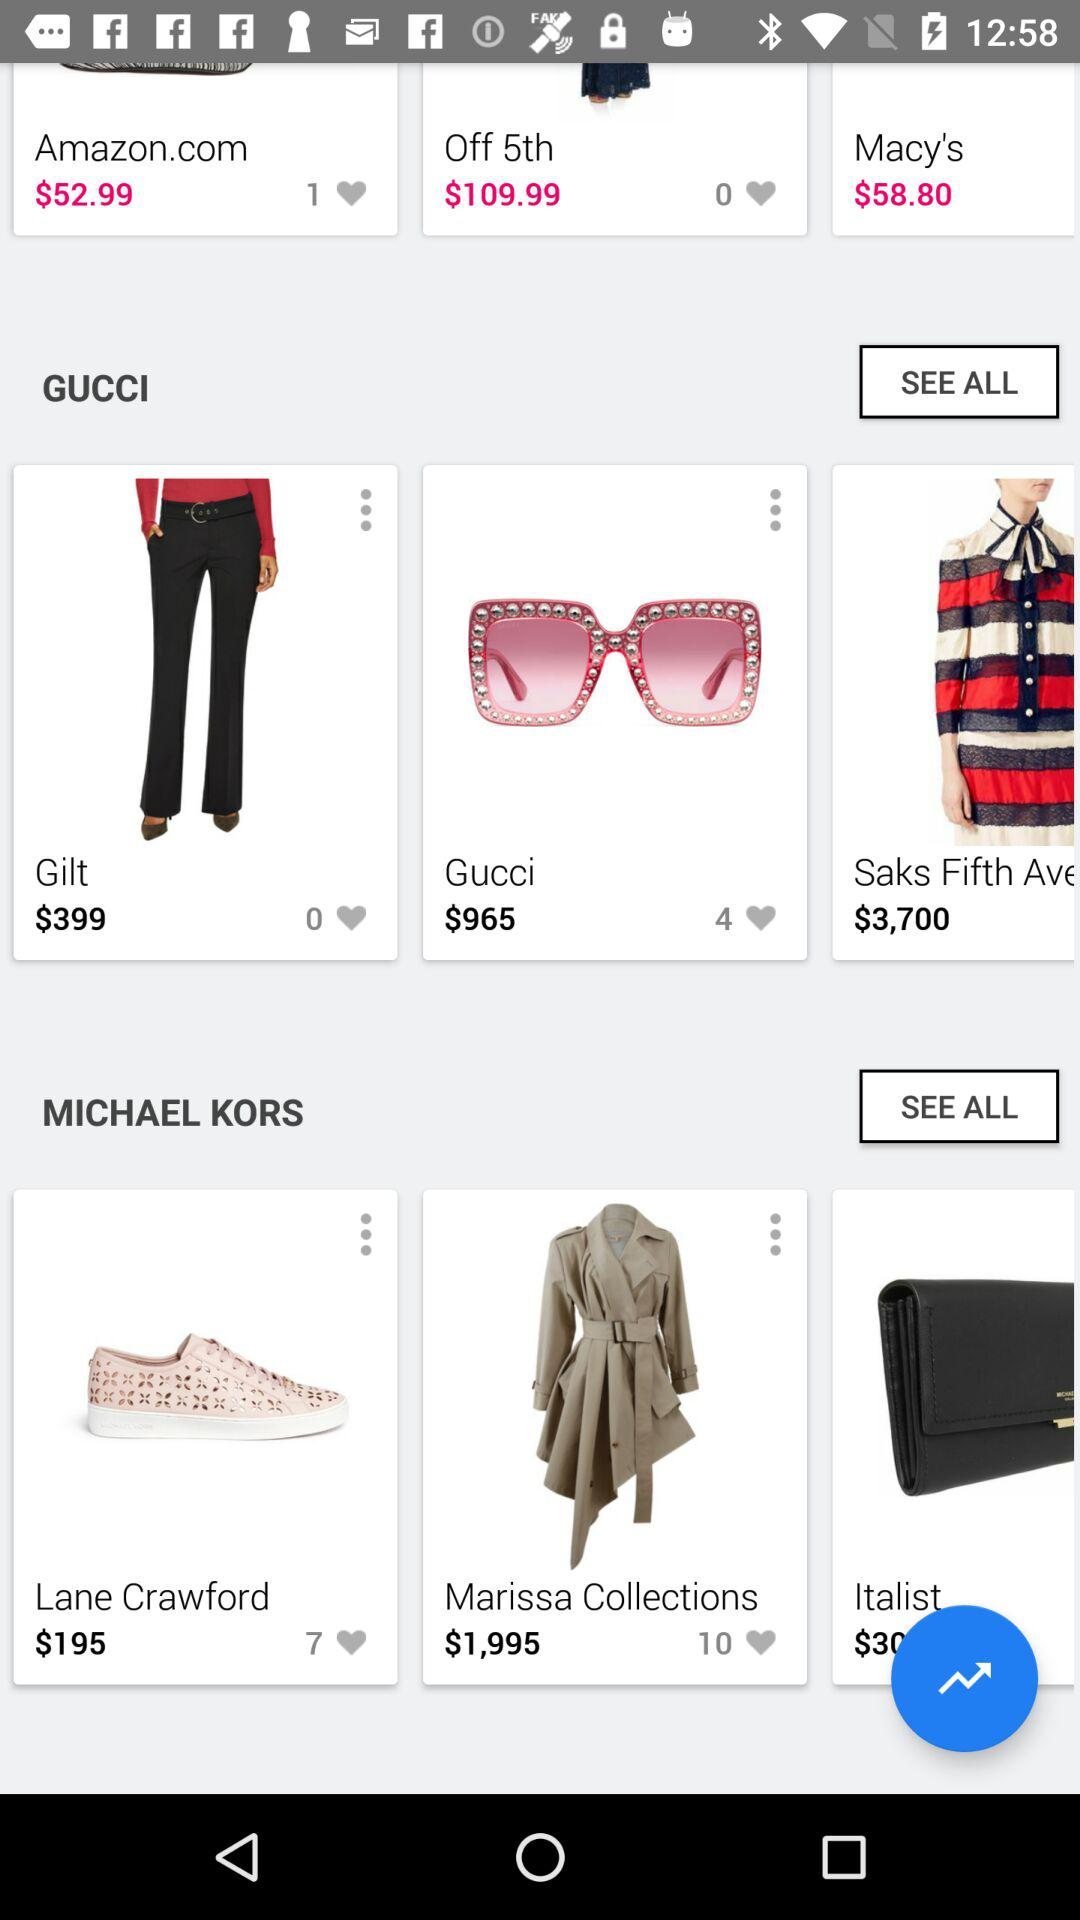How much more expensive is the Gucci sunglasses compared to the Gucci pants?
Answer the question using a single word or phrase. $566 